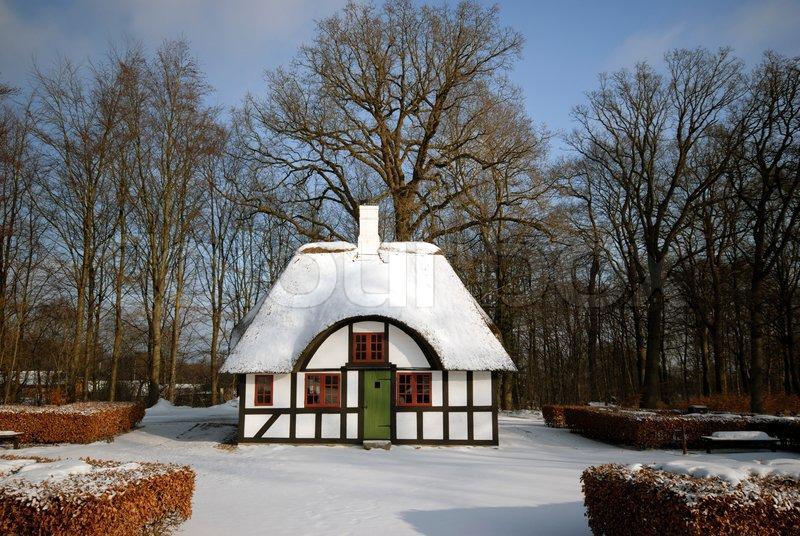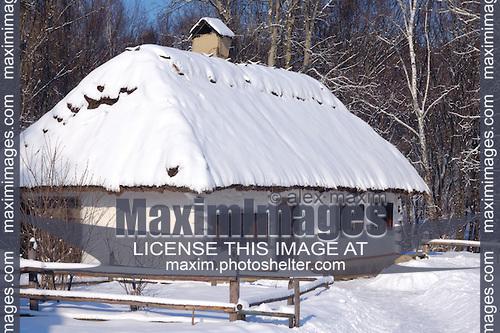The first image is the image on the left, the second image is the image on the right. Given the left and right images, does the statement "There is blue sky in at least one image." hold true? Answer yes or no. Yes. The first image is the image on the left, the second image is the image on the right. Given the left and right images, does the statement "The right image shows snow covering a roof with two notches around paned windows on the upper story." hold true? Answer yes or no. No. 